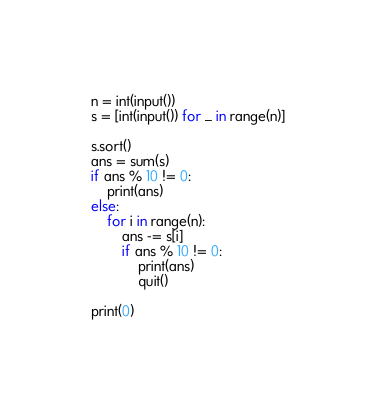Convert code to text. <code><loc_0><loc_0><loc_500><loc_500><_Python_>n = int(input())
s = [int(input()) for _ in range(n)]

s.sort()
ans = sum(s)
if ans % 10 != 0:
    print(ans)
else:
    for i in range(n):
        ans -= s[i]
        if ans % 10 != 0:
            print(ans)
            quit()

print(0)</code> 